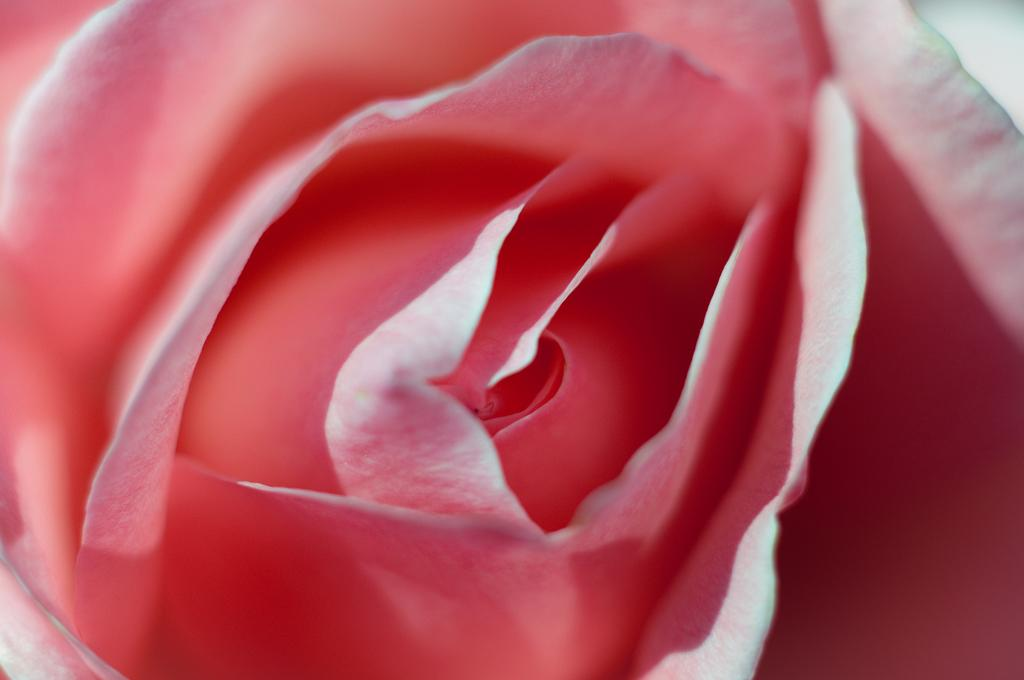What type of flower is present in the image? There is a pink color flower in the image. Is the flower serving as a servant to the crown in the image? There is no crown present in the image, and the flower is not serving as a servant. 